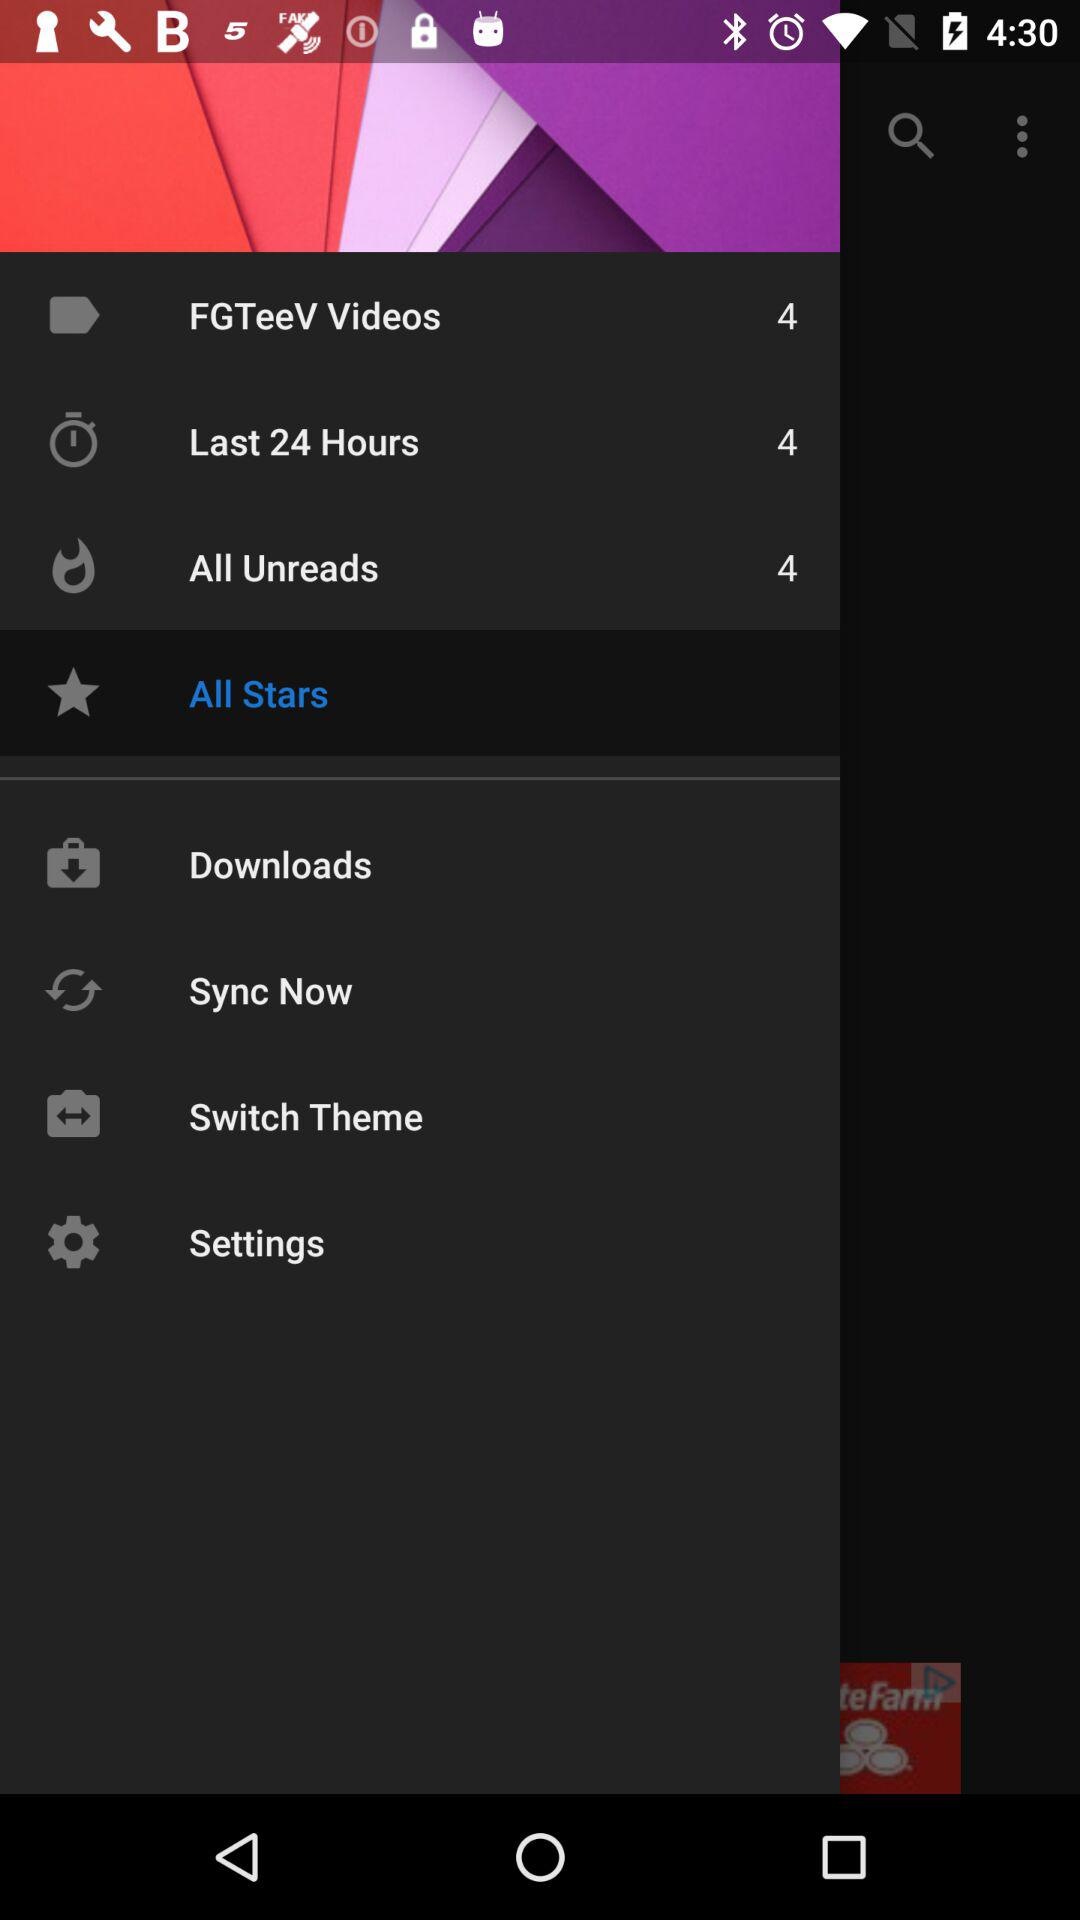What is the selected item? The selected item is "All Stars". 